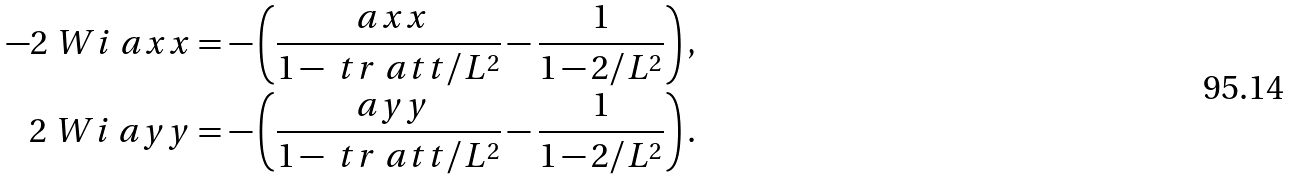<formula> <loc_0><loc_0><loc_500><loc_500>- 2 \ W i \ a x x & = - \left ( \frac { \ a x x } { 1 - \ t r \ a t t / L ^ { 2 } } - \frac { 1 } { 1 - 2 / L ^ { 2 } } \right ) , \\ 2 \ W i \ a y y & = - \left ( \frac { \ a y y } { 1 - \ t r \ a t t / L ^ { 2 } } - \frac { 1 } { 1 - 2 / L ^ { 2 } } \right ) .</formula> 